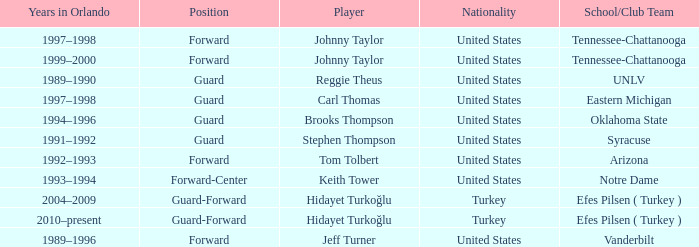What is Stephen Thompson's School/Club Team? Syracuse. 